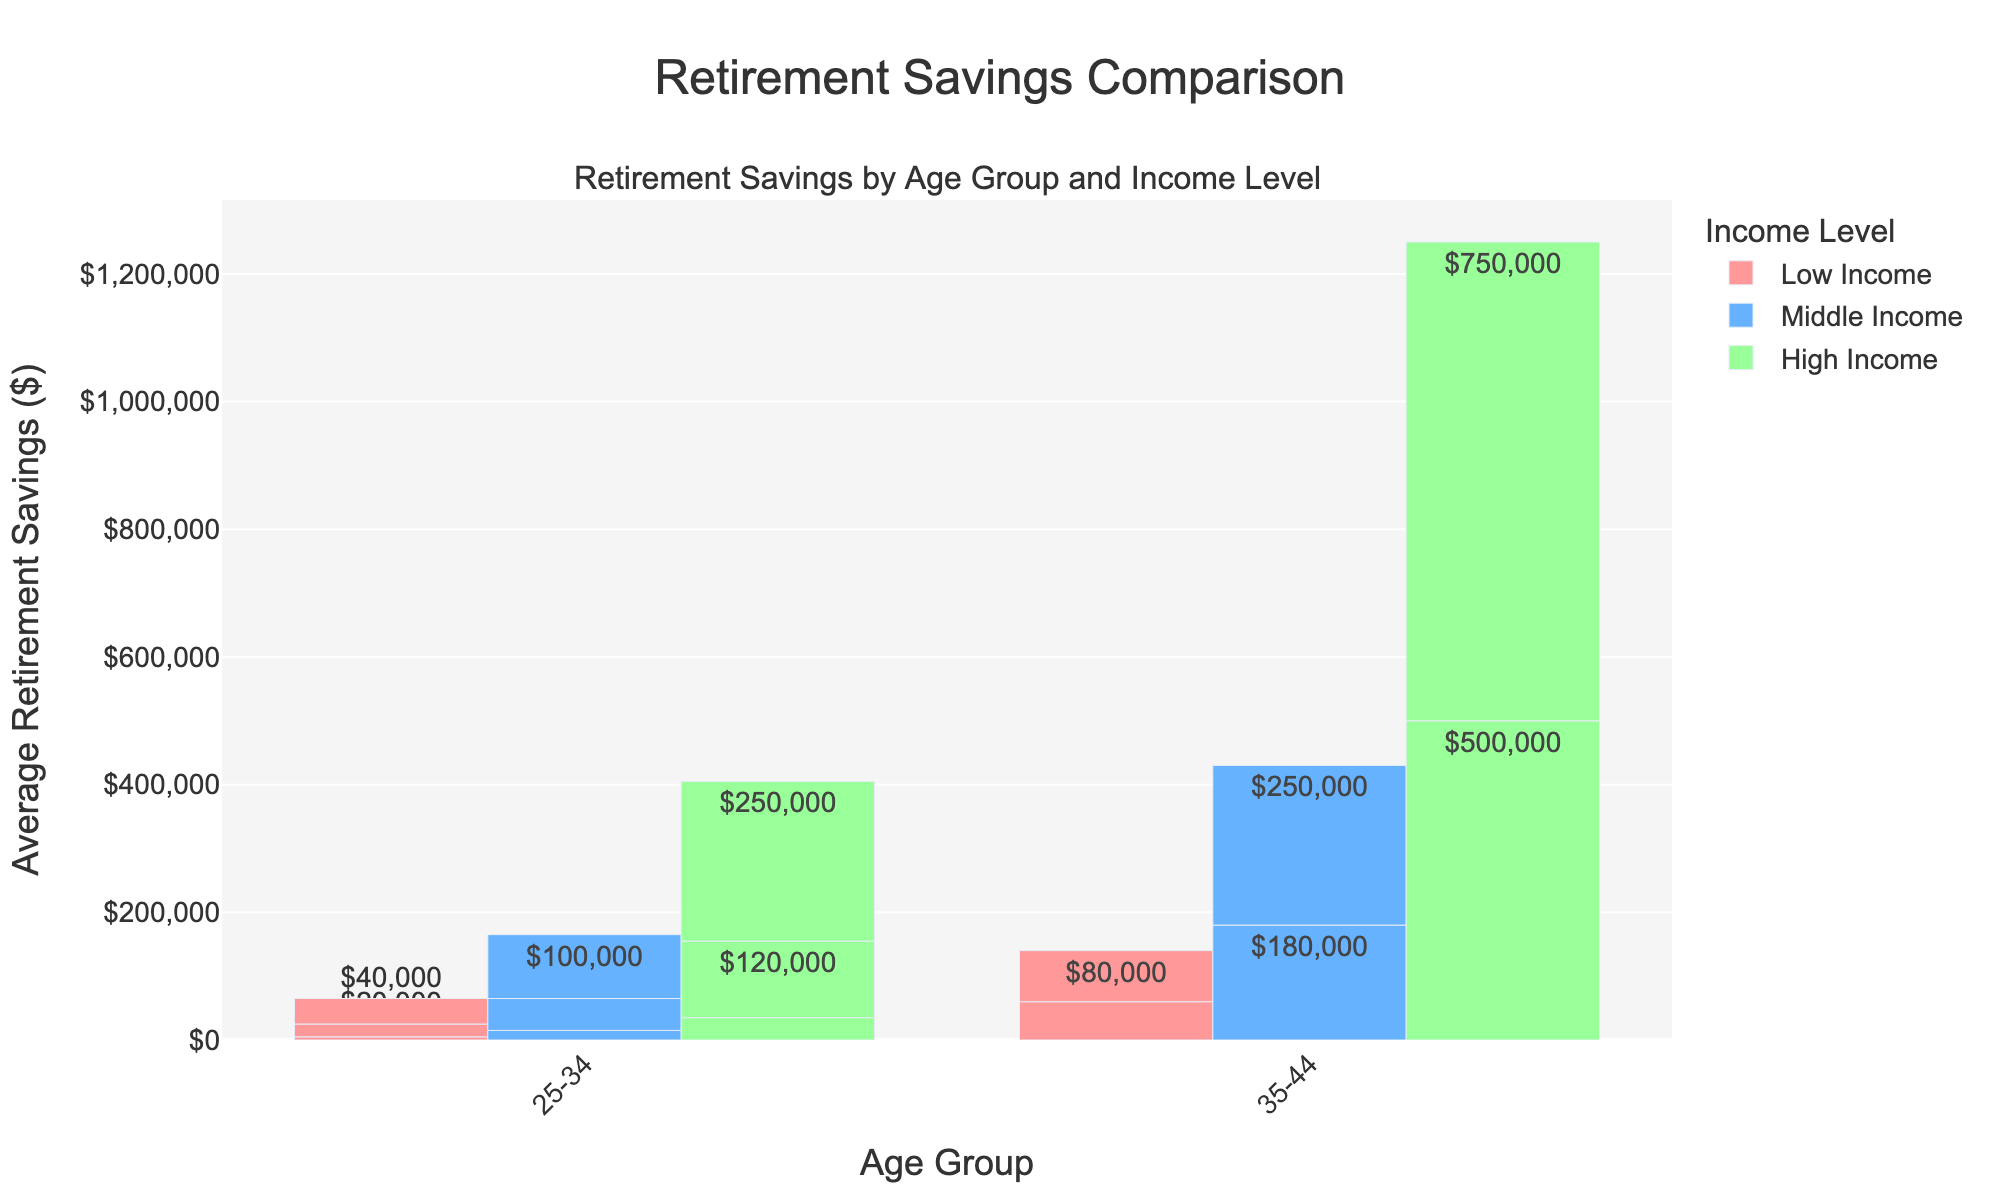What is the average retirement savings for high-income individuals aged 65 and above? The average retirement savings for high-income individuals aged 65 and above is given directly in the figure under the 65+ age group for the high-income category.
Answer: $750,000 Which age group has the highest retirement savings for low-income individuals? To determine this, find the highest bar within the 'Low Income' category across all age groups. The highest bar is found in the 65+ age group.
Answer: 65+ How much more do middle-income individuals in the 55-64 age group save on average compared to low-income individuals in the same age group? Find the average retirement savings for middle-income and low-income individuals in the 55-64 age group. The middle-income group saves $180,000 and the low-income group saves $60,000. Subtract the two values ($180,000 - $60,000).
Answer: $120,000 What is the difference in average retirement savings between high-income individuals aged 35-44 and those aged 45-54? Find the average retirement savings for high-income individuals aged 35-44 ($120,000) and 45-54 ($250,000). Subtract the two values ($250,000 - $120,000).
Answer: $130,000 Which income level has the largest increase in average retirement savings between the age groups 45-54 and 55-64? Compare the increase in average retirement savings for each income level between the age groups 45-54 and 55-64. Low Income increases from $40,000 to $60,000 ($20,000 increase), Middle Income from $100,000 to $180,000 ($80,000 increase), and High Income from $250,000 to $500,000 ($250,000 increase).
Answer: High Income What is the combined average retirement savings for middle-income individuals across all age groups? Summing the average retirement savings for middle-income individuals in each age group: $15,000 (25-34) + $50,000 (35-44) + $100,000 (45-54) + $180,000 (55-64) + $250,000 (65+). The total is $595,000.
Answer: $595,000 Which visual attribute helps differentiate the middle-income retirement savings from the others? The middle-income bars can be identified by their distinct color among the grouped bars.
Answer: Blue Is the difference in retirement savings between the 25-34 and 55-64 age groups larger for high-income or low-income individuals? Compare the differences in retirement savings between the age groups 25-34 and 55-64 for each income level. High Income difference: $500,000 - $35,000 = $465,000, Low Income difference: $60,000 - $5,000 = $55,000.
Answer: High Income 